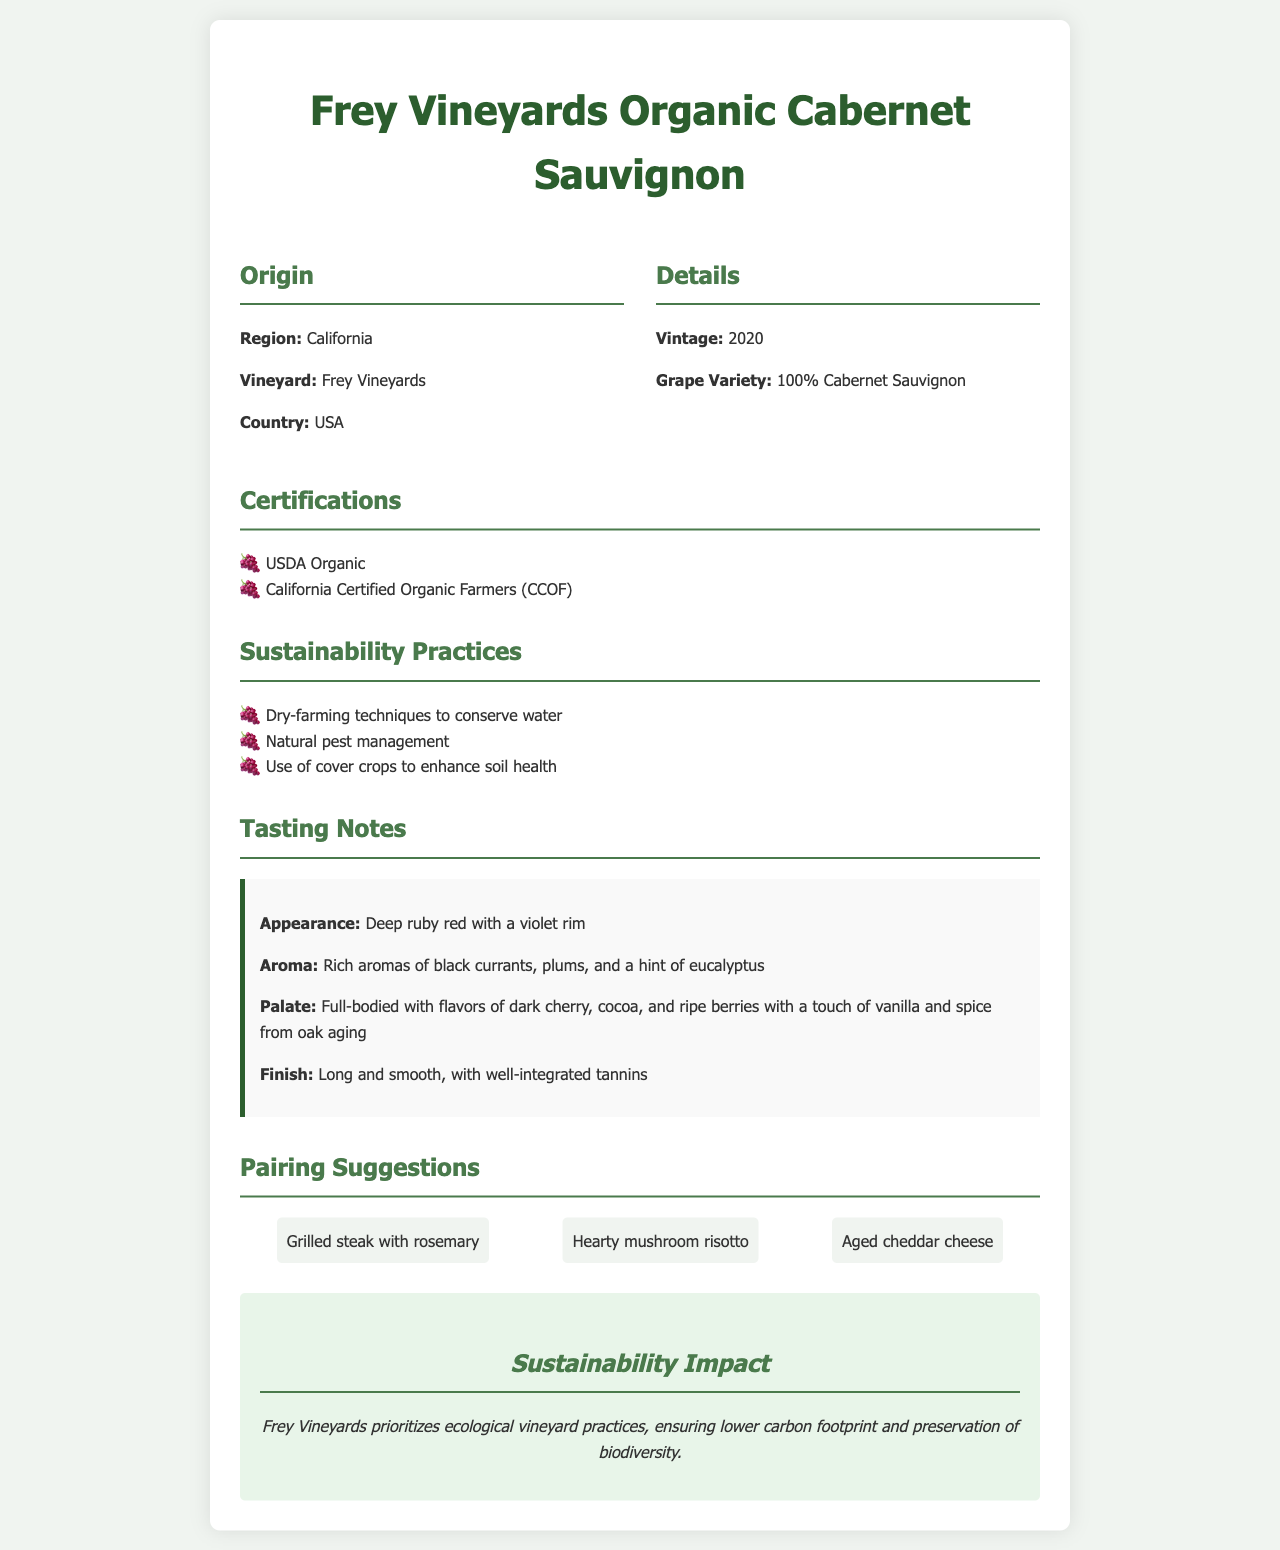What is the wine's origin region? The origin region for the wine is specified as California.
Answer: California What vintage is the Frey Vineyards Organic Cabernet Sauvignon? The vintage is indicated in the details section, which states the year is 2020.
Answer: 2020 What certifications does this wine have? The document lists two certifications: USDA Organic and California Certified Organic Farmers (CCOF).
Answer: USDA Organic, California Certified Organic Farmers (CCOF) What sustainability practice is mentioned for water conservation? The document indicates "Dry-farming techniques to conserve water" as a sustainability practice.
Answer: Dry-farming techniques What are the flavors noted on the palate? The tasting notes section lists various flavors, including dark cherry, cocoa, and ripe berries.
Answer: Dark cherry, cocoa, ripe berries How is the finish of the wine described? The details provided describe the finish as "Long and smooth, with well-integrated tannins."
Answer: Long and smooth What food is suggested for pairing with the wine? The pairing suggestions section mentions several items, one of which is grilled steak.
Answer: Grilled steak What is the key sustainability impact highlighted? The document emphasizes the importance of "lower carbon footprint and preservation of biodiversity."
Answer: Lower carbon footprint and preservation of biodiversity 